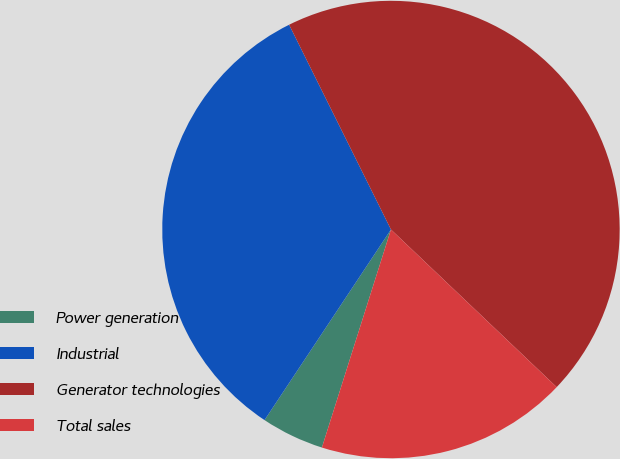Convert chart. <chart><loc_0><loc_0><loc_500><loc_500><pie_chart><fcel>Power generation<fcel>Industrial<fcel>Generator technologies<fcel>Total sales<nl><fcel>4.44%<fcel>33.33%<fcel>44.44%<fcel>17.78%<nl></chart> 